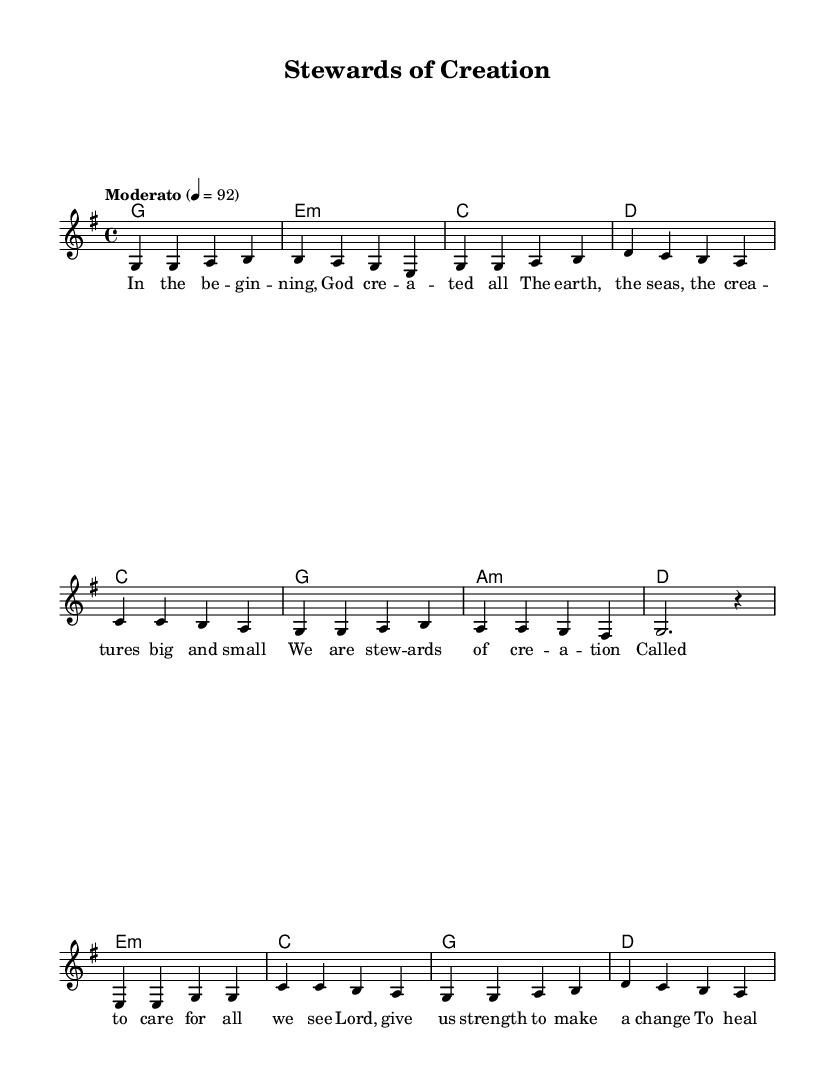What is the key signature of this music? The key signature is G major, which has one sharp (F#). This can be identified by looking at the key signature symbol at the beginning of the staff.
Answer: G major What is the time signature of this music? The time signature is 4/4, which means there are four beats in each measure and the quarter note gets one beat. This is indicated at the beginning of the staff.
Answer: 4/4 What is the tempo marking for this piece? The tempo marking is Moderato. It indicates a moderate pace, usually around 92 beats per minute. This can be found marked on the staff near the beginning.
Answer: Moderato How many verses are present in the lyrics? There is one verse of lyrics provided in the sheet music. This can be confirmed by observing the presence of the lyrics below the melody, and only one verse appears there.
Answer: One What is the last note of the melody in the chorus? The last note of the melody in the chorus is a rest (notated as r4). This can be determined by looking at the last measure of the chorus, which has no note but contains a rest symbol instead.
Answer: Rest What is the tonic chord used in the first verse? The tonic chord used in the first verse is G major. This is established by examining the harmonies provided above the melody where G major is the first chord indicated for the verse.
Answer: G major What theme is highlighted in the lyrics of this song? The theme highlighted in the lyrics is environmental stewardship. This is evident from the phrases that mention caring for creation and healing the earth, indicating a focus on environmental responsibility.
Answer: Environmental stewardship 